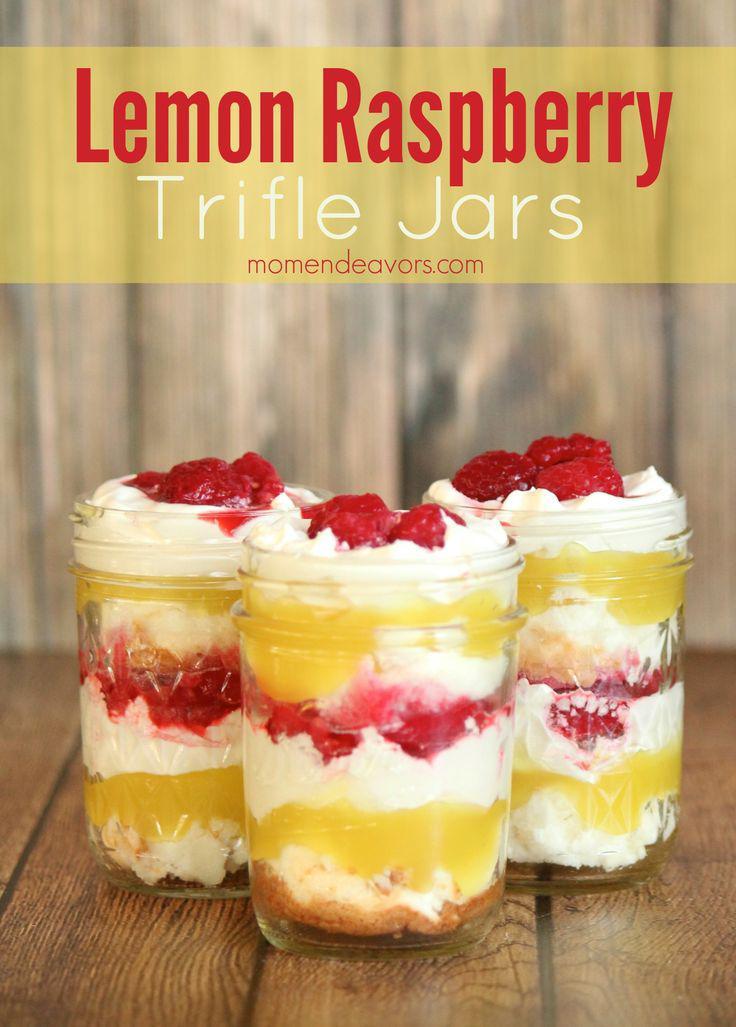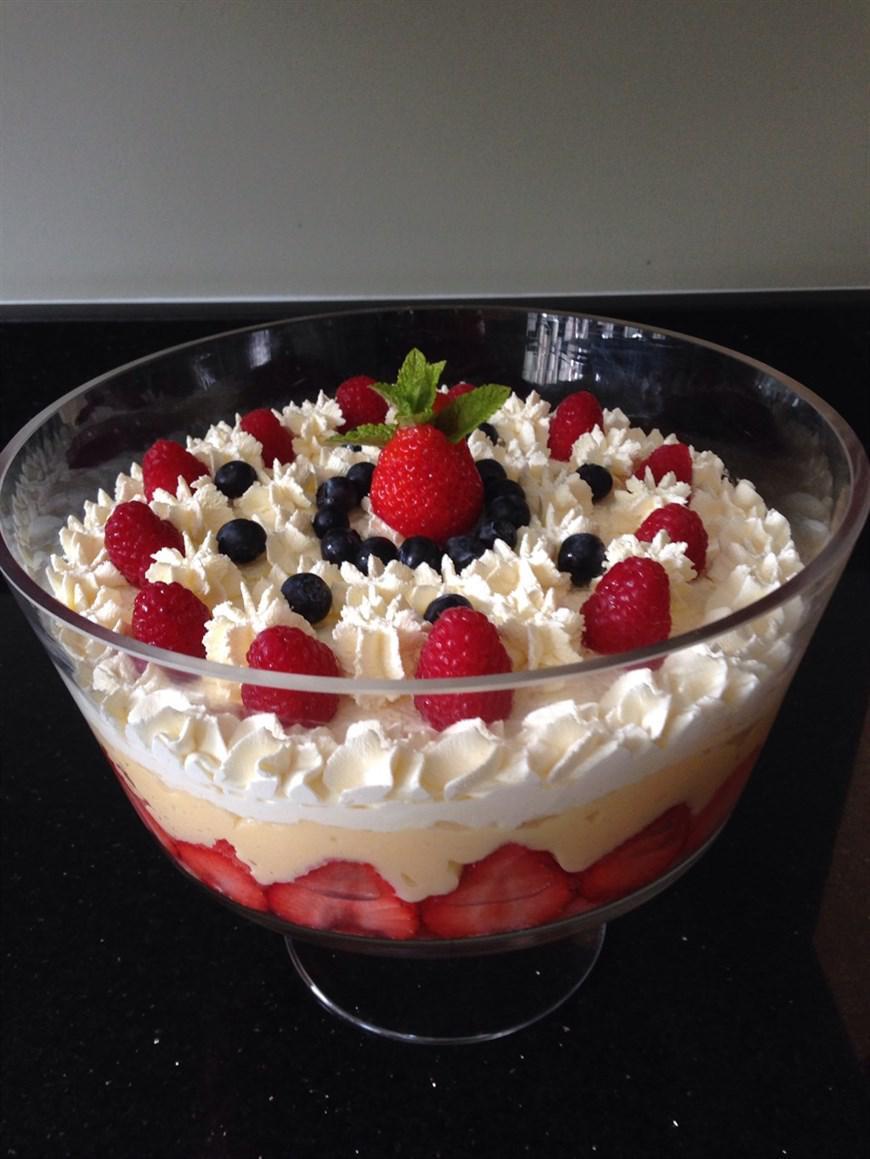The first image is the image on the left, the second image is the image on the right. Assess this claim about the two images: "The desserts in the image on the left are being served in three glasses.". Correct or not? Answer yes or no. Yes. The first image is the image on the left, the second image is the image on the right. Given the left and right images, does the statement "Two large fruit and cream desserts are ready to serve in clear bowls and are garnished with red fruit." hold true? Answer yes or no. No. 